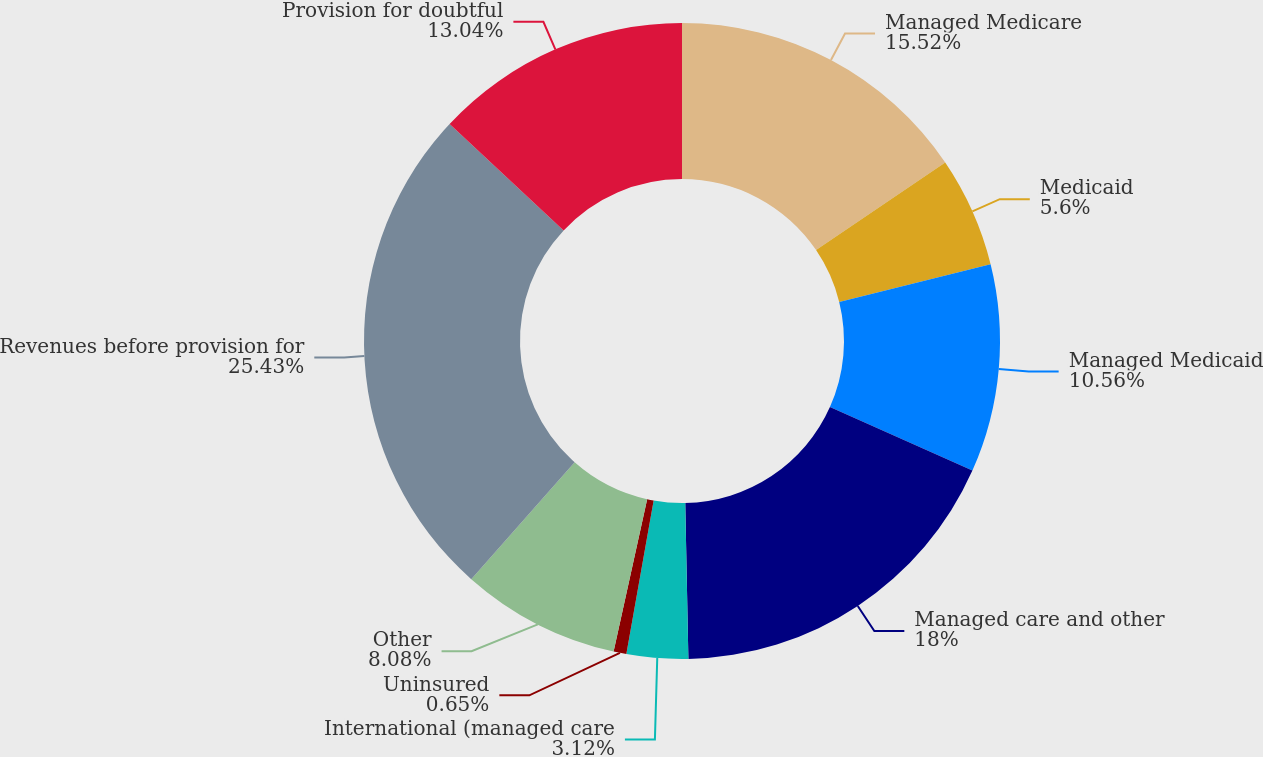<chart> <loc_0><loc_0><loc_500><loc_500><pie_chart><fcel>Managed Medicare<fcel>Medicaid<fcel>Managed Medicaid<fcel>Managed care and other<fcel>International (managed care<fcel>Uninsured<fcel>Other<fcel>Revenues before provision for<fcel>Provision for doubtful<nl><fcel>15.52%<fcel>5.6%<fcel>10.56%<fcel>18.0%<fcel>3.12%<fcel>0.65%<fcel>8.08%<fcel>25.43%<fcel>13.04%<nl></chart> 